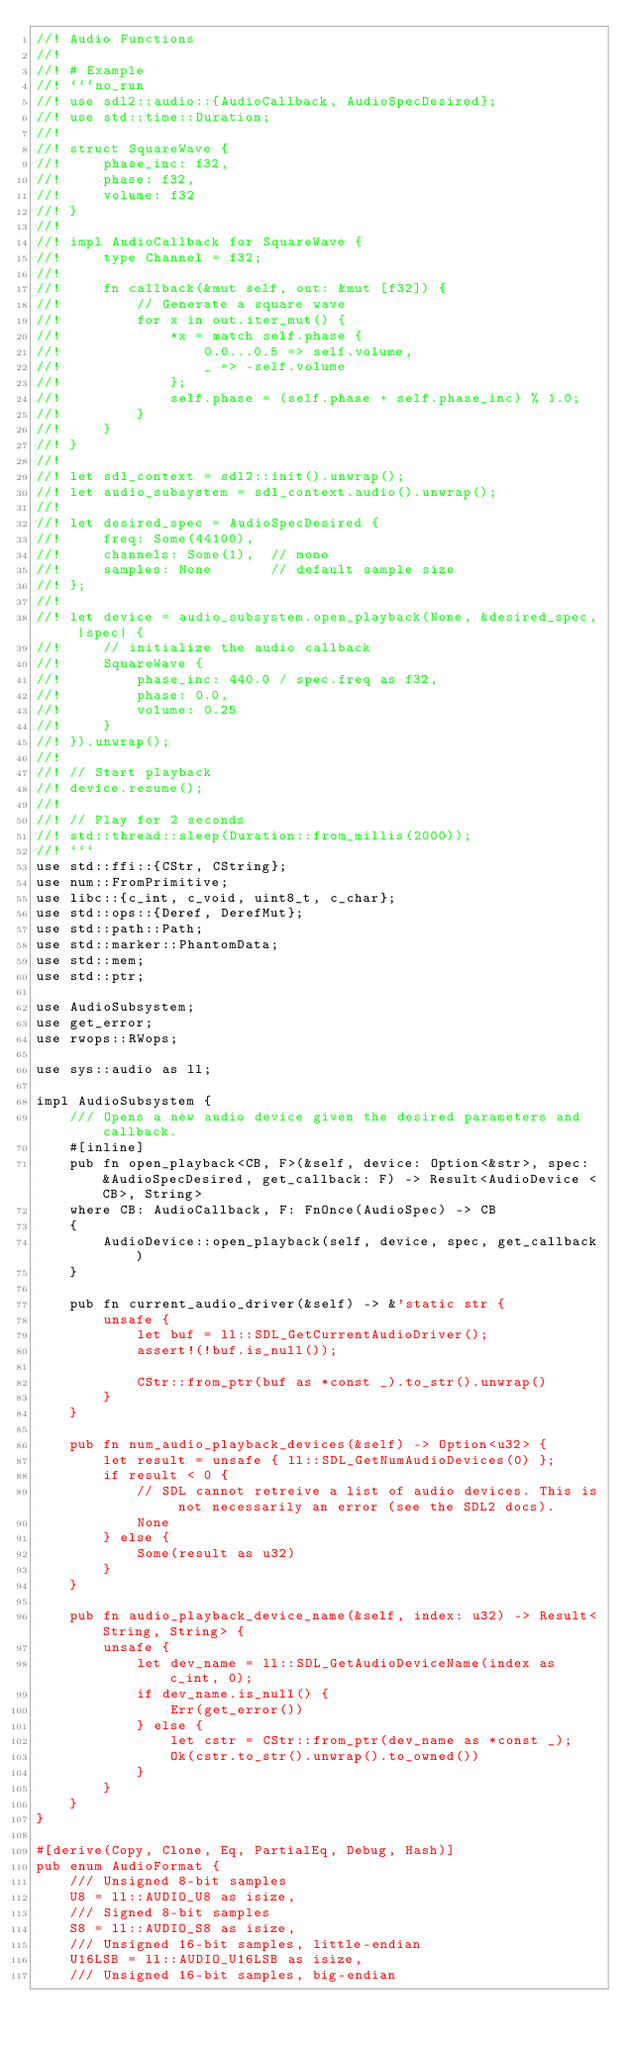<code> <loc_0><loc_0><loc_500><loc_500><_Rust_>//! Audio Functions
//!
//! # Example
//! ```no_run
//! use sdl2::audio::{AudioCallback, AudioSpecDesired};
//! use std::time::Duration;
//!
//! struct SquareWave {
//!     phase_inc: f32,
//!     phase: f32,
//!     volume: f32
//! }
//!
//! impl AudioCallback for SquareWave {
//!     type Channel = f32;
//!
//!     fn callback(&mut self, out: &mut [f32]) {
//!         // Generate a square wave
//!         for x in out.iter_mut() {
//!             *x = match self.phase {
//!                 0.0...0.5 => self.volume,
//!                 _ => -self.volume
//!             };
//!             self.phase = (self.phase + self.phase_inc) % 1.0;
//!         }
//!     }
//! }
//!
//! let sdl_context = sdl2::init().unwrap();
//! let audio_subsystem = sdl_context.audio().unwrap();
//!
//! let desired_spec = AudioSpecDesired {
//!     freq: Some(44100),
//!     channels: Some(1),  // mono
//!     samples: None       // default sample size
//! };
//!
//! let device = audio_subsystem.open_playback(None, &desired_spec, |spec| {
//!     // initialize the audio callback
//!     SquareWave {
//!         phase_inc: 440.0 / spec.freq as f32,
//!         phase: 0.0,
//!         volume: 0.25
//!     }
//! }).unwrap();
//!
//! // Start playback
//! device.resume();
//!
//! // Play for 2 seconds
//! std::thread::sleep(Duration::from_millis(2000));
//! ```
use std::ffi::{CStr, CString};
use num::FromPrimitive;
use libc::{c_int, c_void, uint8_t, c_char};
use std::ops::{Deref, DerefMut};
use std::path::Path;
use std::marker::PhantomData;
use std::mem;
use std::ptr;

use AudioSubsystem;
use get_error;
use rwops::RWops;

use sys::audio as ll;

impl AudioSubsystem {
    /// Opens a new audio device given the desired parameters and callback.
    #[inline]
    pub fn open_playback<CB, F>(&self, device: Option<&str>, spec: &AudioSpecDesired, get_callback: F) -> Result<AudioDevice <CB>, String>
    where CB: AudioCallback, F: FnOnce(AudioSpec) -> CB
    {
        AudioDevice::open_playback(self, device, spec, get_callback)
    }

    pub fn current_audio_driver(&self) -> &'static str {
        unsafe {
            let buf = ll::SDL_GetCurrentAudioDriver();
            assert!(!buf.is_null());

            CStr::from_ptr(buf as *const _).to_str().unwrap()
        }
    }

    pub fn num_audio_playback_devices(&self) -> Option<u32> {
        let result = unsafe { ll::SDL_GetNumAudioDevices(0) };
        if result < 0 {
            // SDL cannot retreive a list of audio devices. This is not necessarily an error (see the SDL2 docs).
            None
        } else {
            Some(result as u32)
        }
    }

    pub fn audio_playback_device_name(&self, index: u32) -> Result<String, String> {
        unsafe {
            let dev_name = ll::SDL_GetAudioDeviceName(index as c_int, 0);
            if dev_name.is_null() {
                Err(get_error())
            } else {
                let cstr = CStr::from_ptr(dev_name as *const _);
                Ok(cstr.to_str().unwrap().to_owned())
            }
        }
    }
}

#[derive(Copy, Clone, Eq, PartialEq, Debug, Hash)]
pub enum AudioFormat {
    /// Unsigned 8-bit samples
    U8 = ll::AUDIO_U8 as isize,
    /// Signed 8-bit samples
    S8 = ll::AUDIO_S8 as isize,
    /// Unsigned 16-bit samples, little-endian
    U16LSB = ll::AUDIO_U16LSB as isize,
    /// Unsigned 16-bit samples, big-endian</code> 